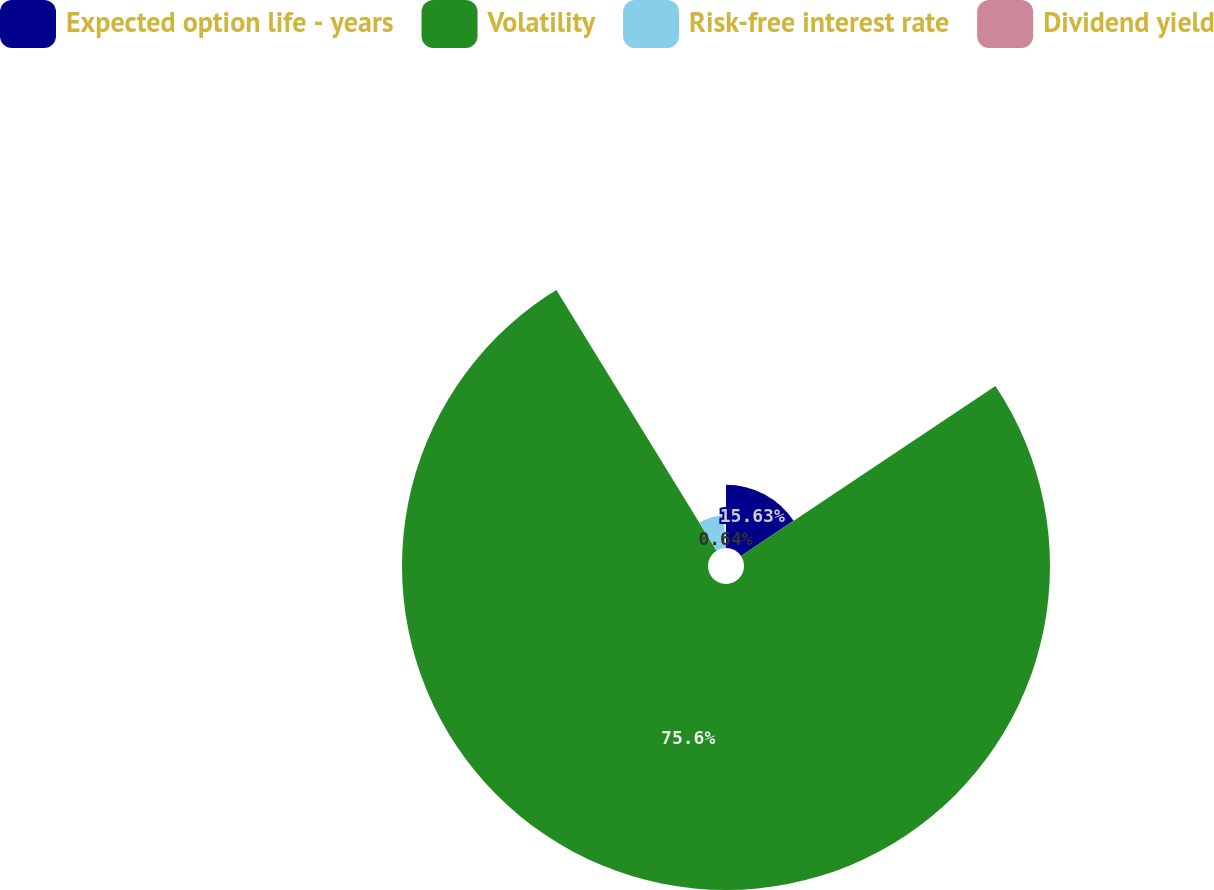<chart> <loc_0><loc_0><loc_500><loc_500><pie_chart><fcel>Expected option life - years<fcel>Volatility<fcel>Risk-free interest rate<fcel>Dividend yield<nl><fcel>15.63%<fcel>75.6%<fcel>8.13%<fcel>0.64%<nl></chart> 